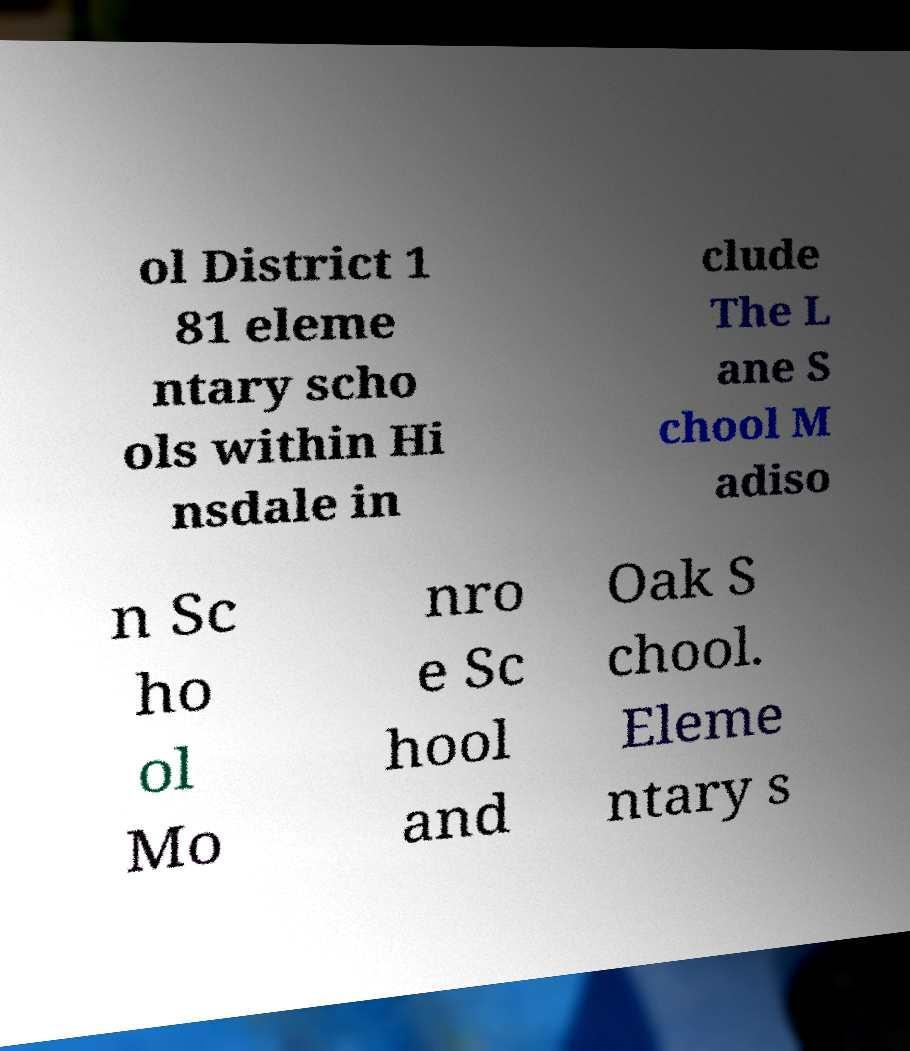There's text embedded in this image that I need extracted. Can you transcribe it verbatim? ol District 1 81 eleme ntary scho ols within Hi nsdale in clude The L ane S chool M adiso n Sc ho ol Mo nro e Sc hool and Oak S chool. Eleme ntary s 